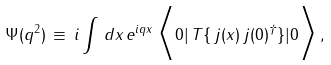Convert formula to latex. <formula><loc_0><loc_0><loc_500><loc_500>\Psi ( q ^ { 2 } ) \, \equiv \, i \int \, d x \, e ^ { i q x } \, \Big < 0 | \, T \{ \, j ( x ) \, j ( 0 ) ^ { \dagger } \} | 0 \Big > \, ,</formula> 